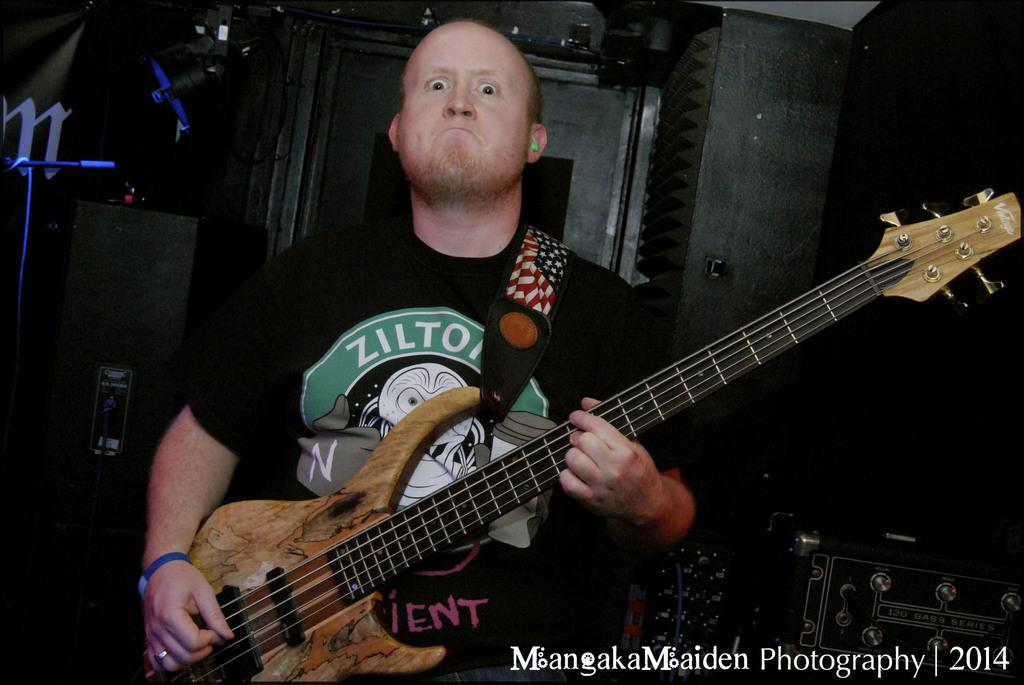What is the man in the image doing? The man is playing the guitar in the image. What is the man's facial expression? The man has a fiery expression in the image. What can be seen behind the man? There are lights behind the man in the image. What other items are visible in the image? There is other equipment visible in the image. Can you tell me how many owls are sitting on the guitar in the image? There are no owls present in the image; the man is playing the guitar without any owls. What type of dish is the man cooking in the image? There is no cooking or dish present in the image; the man is playing the guitar. 